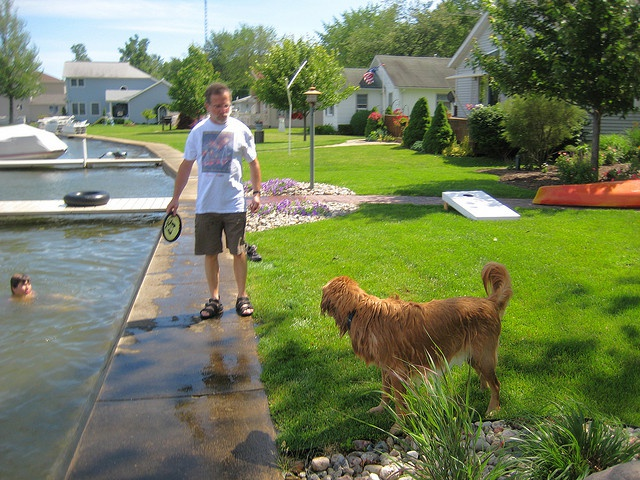Describe the objects in this image and their specific colors. I can see dog in darkgray, olive, maroon, black, and brown tones, people in darkgray, gray, and black tones, boat in darkgray, brown, tan, and black tones, boat in darkgray, white, and gray tones, and people in darkgray, gray, tan, and black tones in this image. 